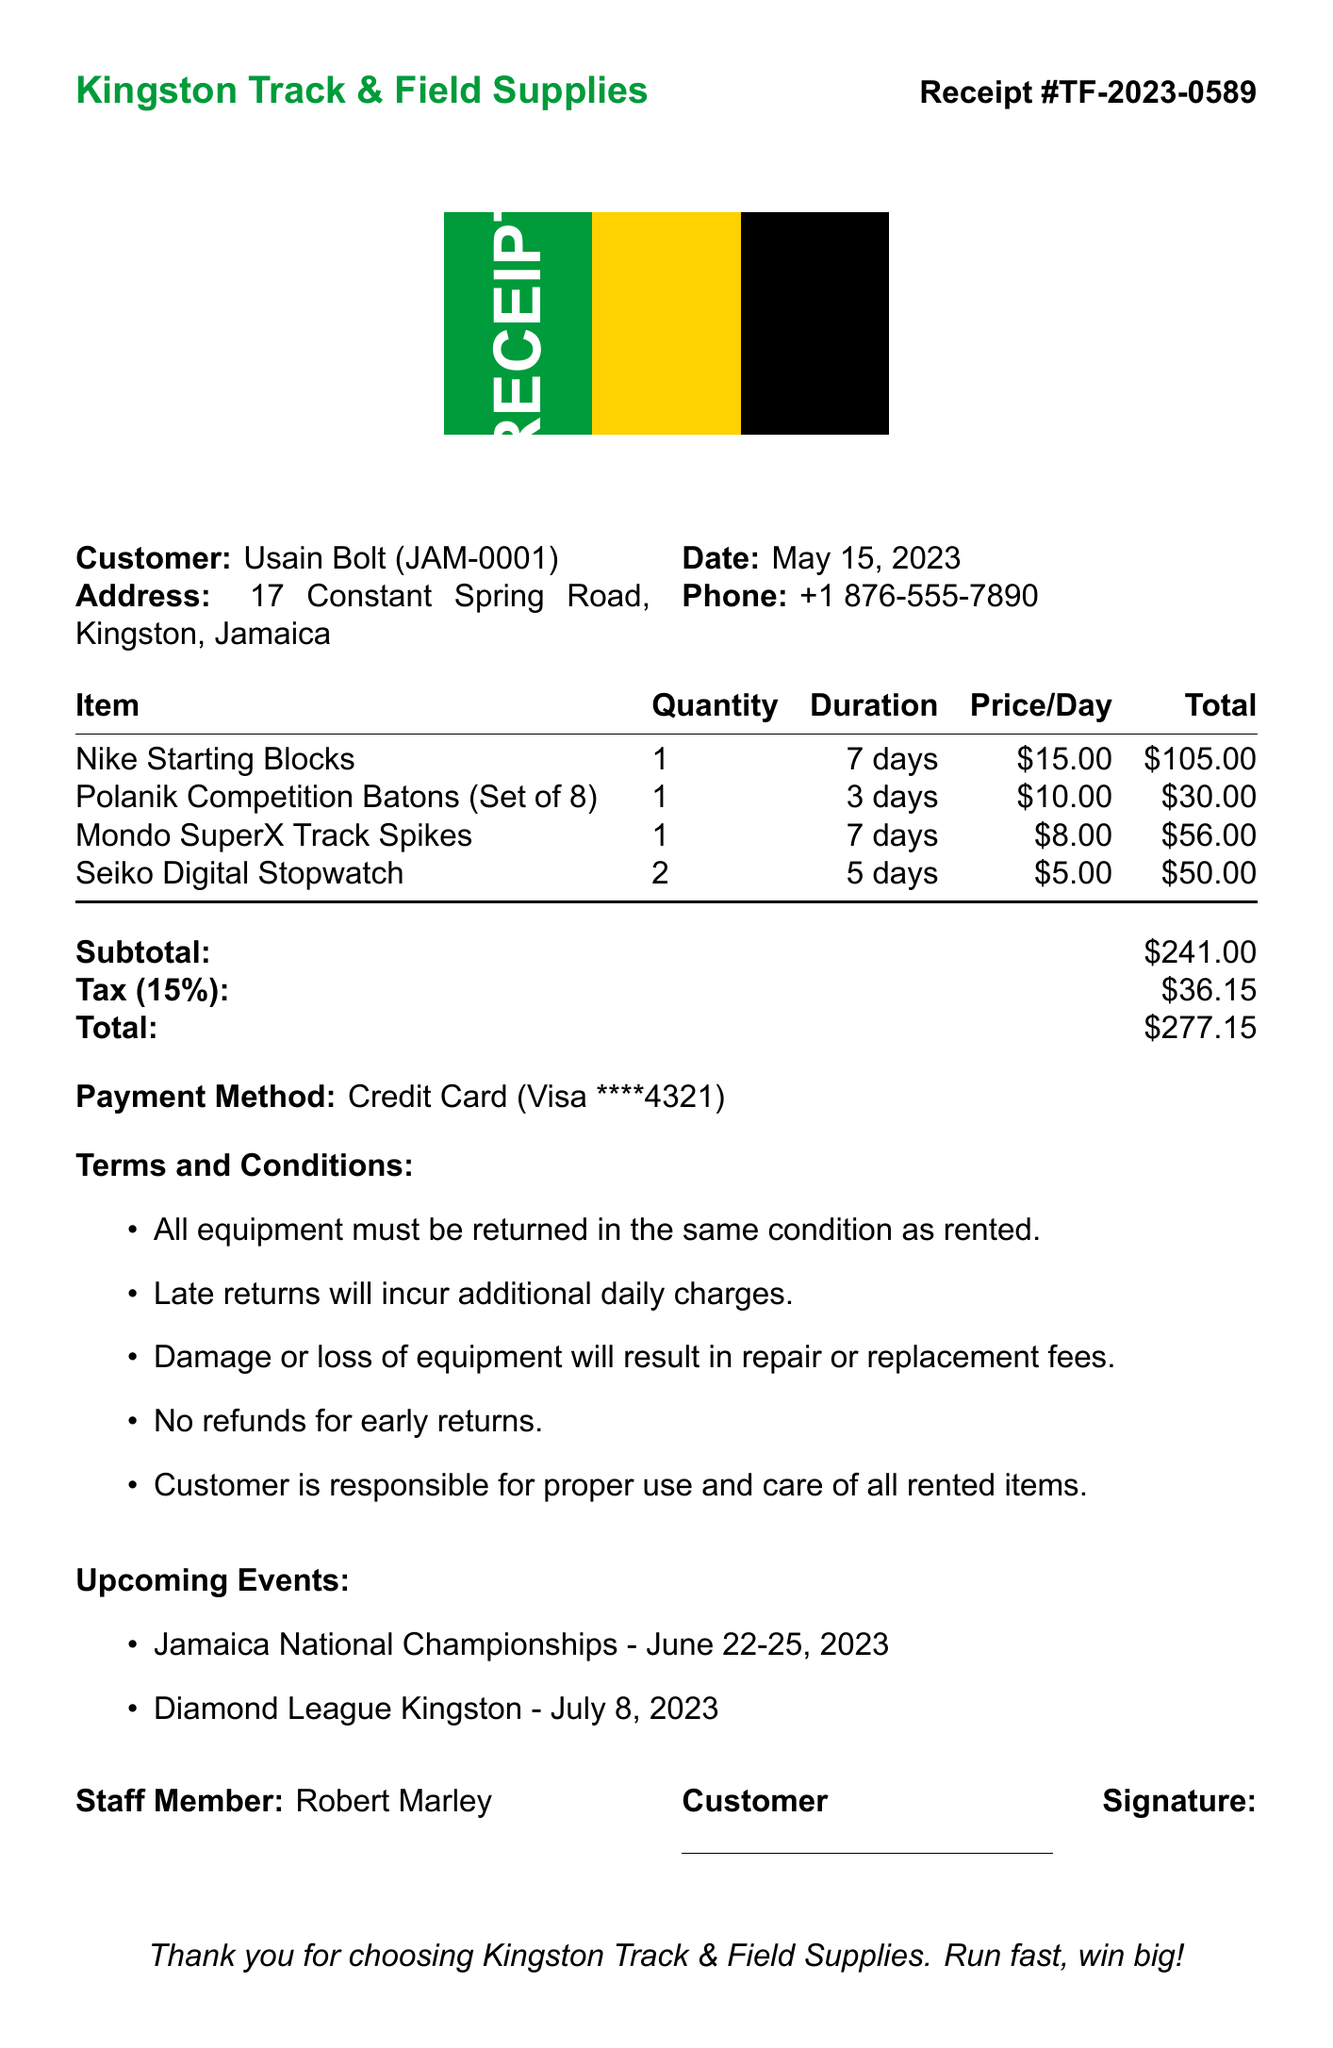What is the receipt number? The receipt number is specified as TF-2023-0589 in the document.
Answer: TF-2023-0589 What is the rental duration for the Nike Starting Blocks? The rental duration for the Nike Starting Blocks is listed as 7 days in the document.
Answer: 7 days How much was the tax amount? The tax amount is calculated and displayed as $36.15 in the document.
Answer: $36.15 What items were rented? The document lists Nike Starting Blocks, Polanik Competition Batons, Mondo SuperX Track Spikes, and Seiko Digital Stopwatch as the rented items.
Answer: Nike Starting Blocks, Polanik Competition Batons, Mondo SuperX Track Spikes, Seiko Digital Stopwatch Who is the staff member that assisted with the rental? The staff member's name, mentioned in the document, is Robert Marley.
Answer: Robert Marley What is the total amount due? The total amount due is the final charge specified as $277.15 in the document.
Answer: $277.15 What are the upcoming events mentioned? The document mentions the Jamaica National Championships and Diamond League Kingston as the upcoming events.
Answer: Jamaica National Championships, Diamond League Kingston How many Seiko Digital Stopwatches were rented? The quantity of Seiko Digital Stopwatches rented is shown as 2 in the document.
Answer: 2 What payment method was used? The payment method used is described as Credit Card (Visa) in the document.
Answer: Credit Card (Visa) 